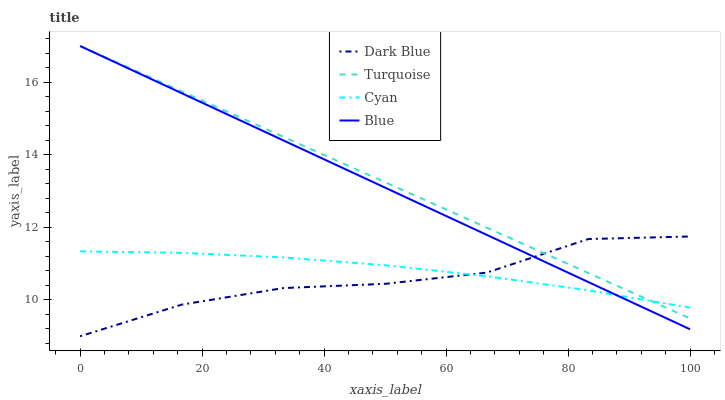Does Dark Blue have the minimum area under the curve?
Answer yes or no. Yes. Does Turquoise have the maximum area under the curve?
Answer yes or no. Yes. Does Turquoise have the minimum area under the curve?
Answer yes or no. No. Does Dark Blue have the maximum area under the curve?
Answer yes or no. No. Is Blue the smoothest?
Answer yes or no. Yes. Is Dark Blue the roughest?
Answer yes or no. Yes. Is Dark Blue the smoothest?
Answer yes or no. No. Is Turquoise the roughest?
Answer yes or no. No. Does Dark Blue have the lowest value?
Answer yes or no. Yes. Does Turquoise have the lowest value?
Answer yes or no. No. Does Turquoise have the highest value?
Answer yes or no. Yes. Does Dark Blue have the highest value?
Answer yes or no. No. Does Turquoise intersect Cyan?
Answer yes or no. Yes. Is Turquoise less than Cyan?
Answer yes or no. No. Is Turquoise greater than Cyan?
Answer yes or no. No. 